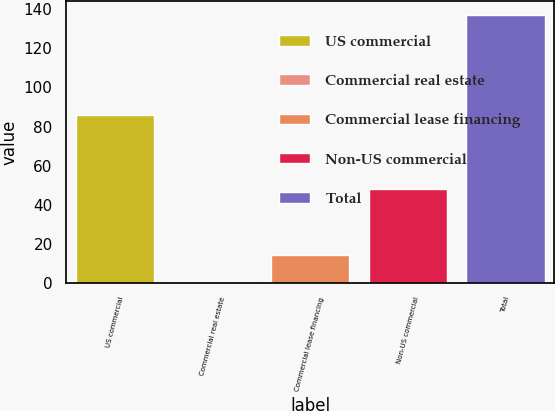Convert chart. <chart><loc_0><loc_0><loc_500><loc_500><bar_chart><fcel>US commercial<fcel>Commercial real estate<fcel>Commercial lease financing<fcel>Non-US commercial<fcel>Total<nl><fcel>86<fcel>1<fcel>14.6<fcel>48<fcel>137<nl></chart> 